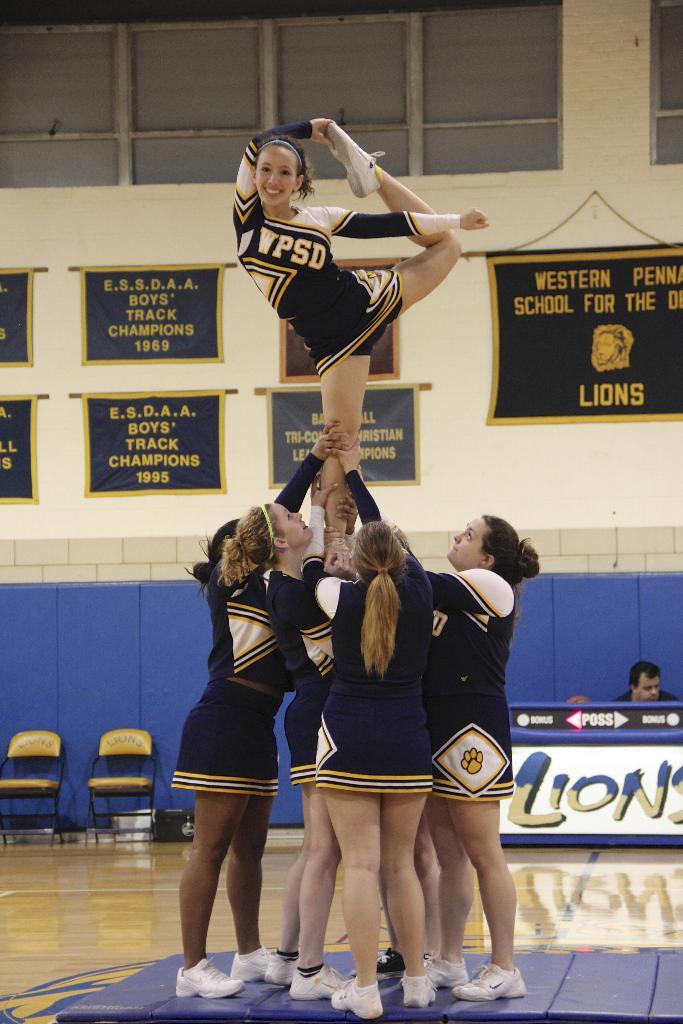Provide a one-sentence caption for the provided image. A load of cheerleaders with wpds uniforms, one of whom is being lifted. 